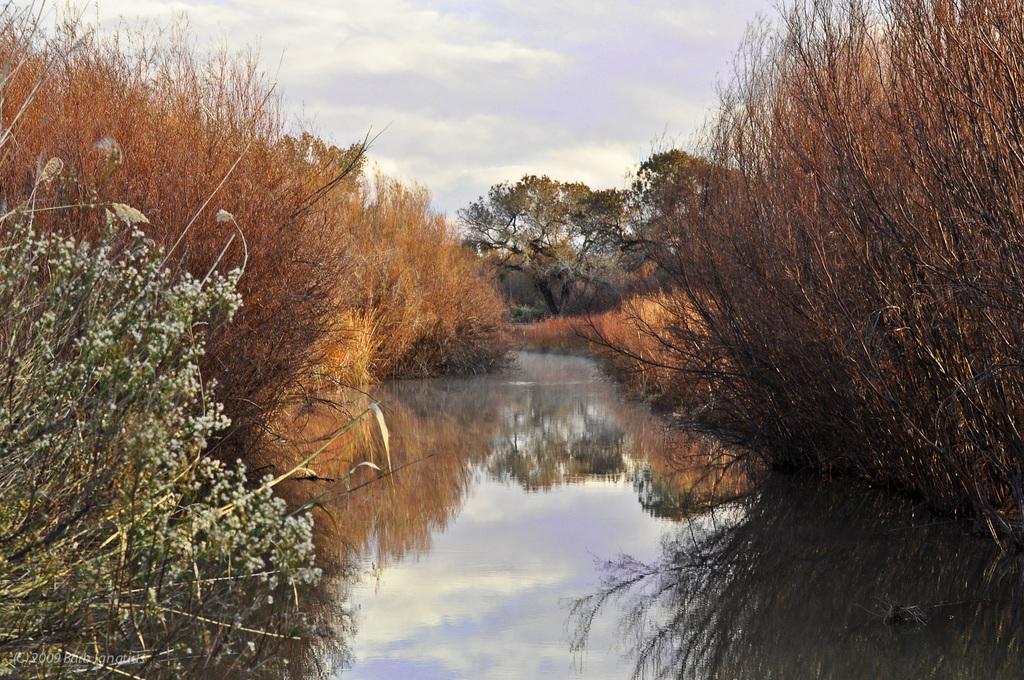Can you describe this image briefly? On the right and left side of the image we can see trees and plants. In the center of the image there is water. In the background we can see trees, sky and clouds. 